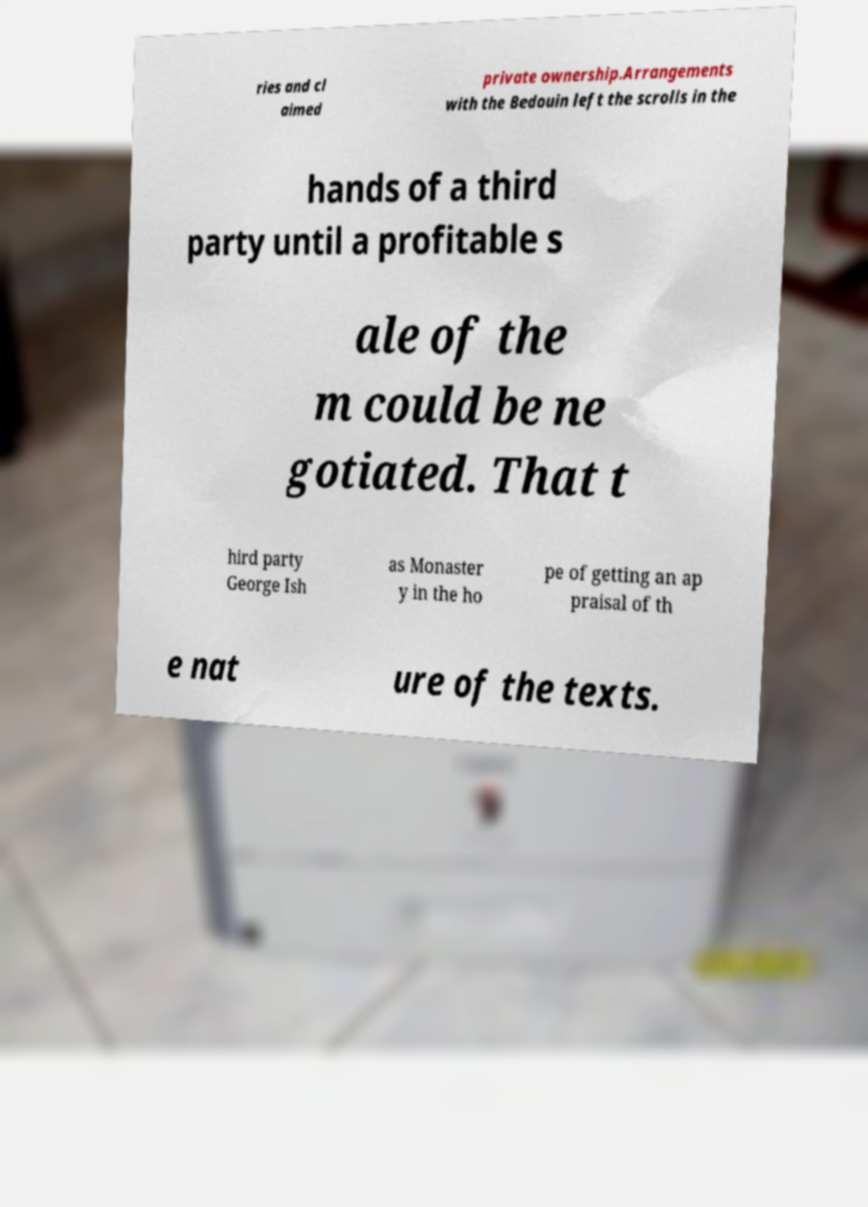What messages or text are displayed in this image? I need them in a readable, typed format. ries and cl aimed private ownership.Arrangements with the Bedouin left the scrolls in the hands of a third party until a profitable s ale of the m could be ne gotiated. That t hird party George Ish as Monaster y in the ho pe of getting an ap praisal of th e nat ure of the texts. 